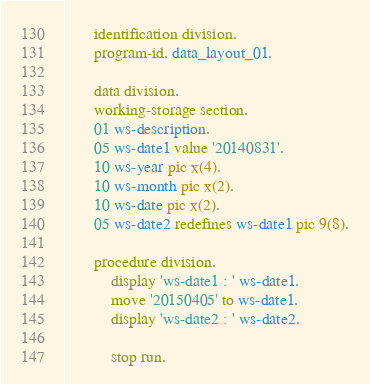Convert code to text. <code><loc_0><loc_0><loc_500><loc_500><_COBOL_>       identification division.
       program-id. data_layout_01.

       data division.
       working-storage section.
       01 ws-description.
       05 ws-date1 value '20140831'.
       10 ws-year pic x(4).
       10 ws-month pic x(2).
       10 ws-date pic x(2).
       05 ws-date2 redefines ws-date1 pic 9(8).

       procedure division.
           display 'ws-date1 : ' ws-date1.
           move '20150405' to ws-date1.
           display 'ws-date2 : ' ws-date2.

           stop run.
</code> 